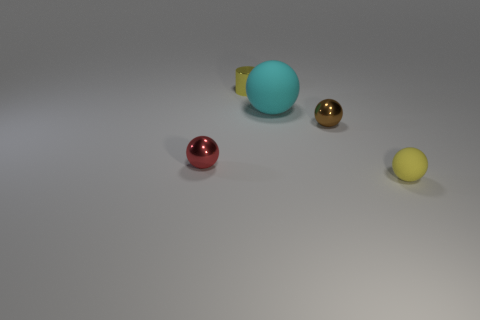Add 2 large cylinders. How many objects exist? 7 Subtract all spheres. How many objects are left? 1 Add 5 cyan matte balls. How many cyan matte balls are left? 6 Add 1 tiny yellow cylinders. How many tiny yellow cylinders exist? 2 Subtract 0 gray balls. How many objects are left? 5 Subtract all rubber objects. Subtract all brown shiny spheres. How many objects are left? 2 